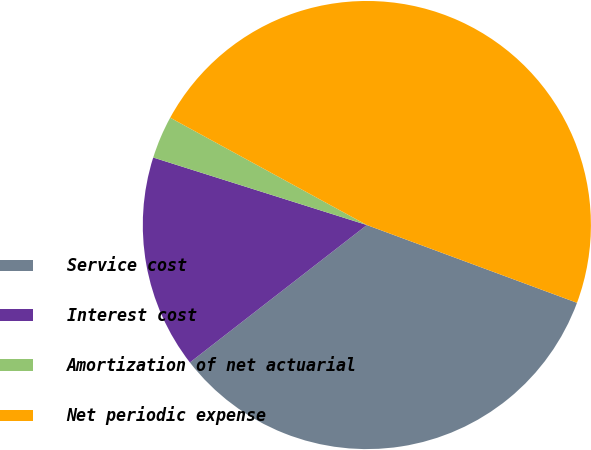Convert chart to OTSL. <chart><loc_0><loc_0><loc_500><loc_500><pie_chart><fcel>Service cost<fcel>Interest cost<fcel>Amortization of net actuarial<fcel>Net periodic expense<nl><fcel>33.85%<fcel>15.38%<fcel>3.08%<fcel>47.69%<nl></chart> 